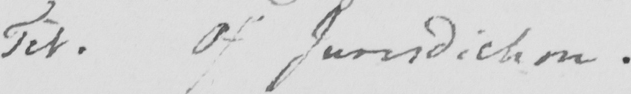Can you tell me what this handwritten text says? Tit. Of Jurisdiction. 